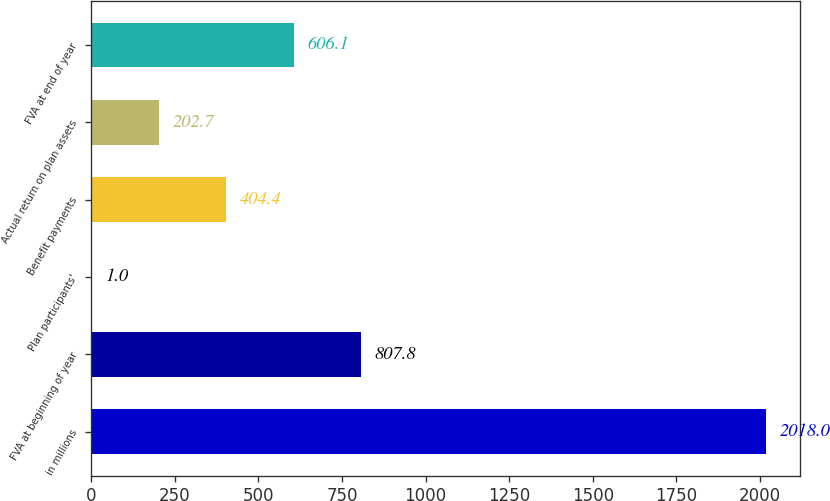Convert chart to OTSL. <chart><loc_0><loc_0><loc_500><loc_500><bar_chart><fcel>in millions<fcel>FVA at beginning of year<fcel>Plan participants'<fcel>Benefit payments<fcel>Actual return on plan assets<fcel>FVA at end of year<nl><fcel>2018<fcel>807.8<fcel>1<fcel>404.4<fcel>202.7<fcel>606.1<nl></chart> 